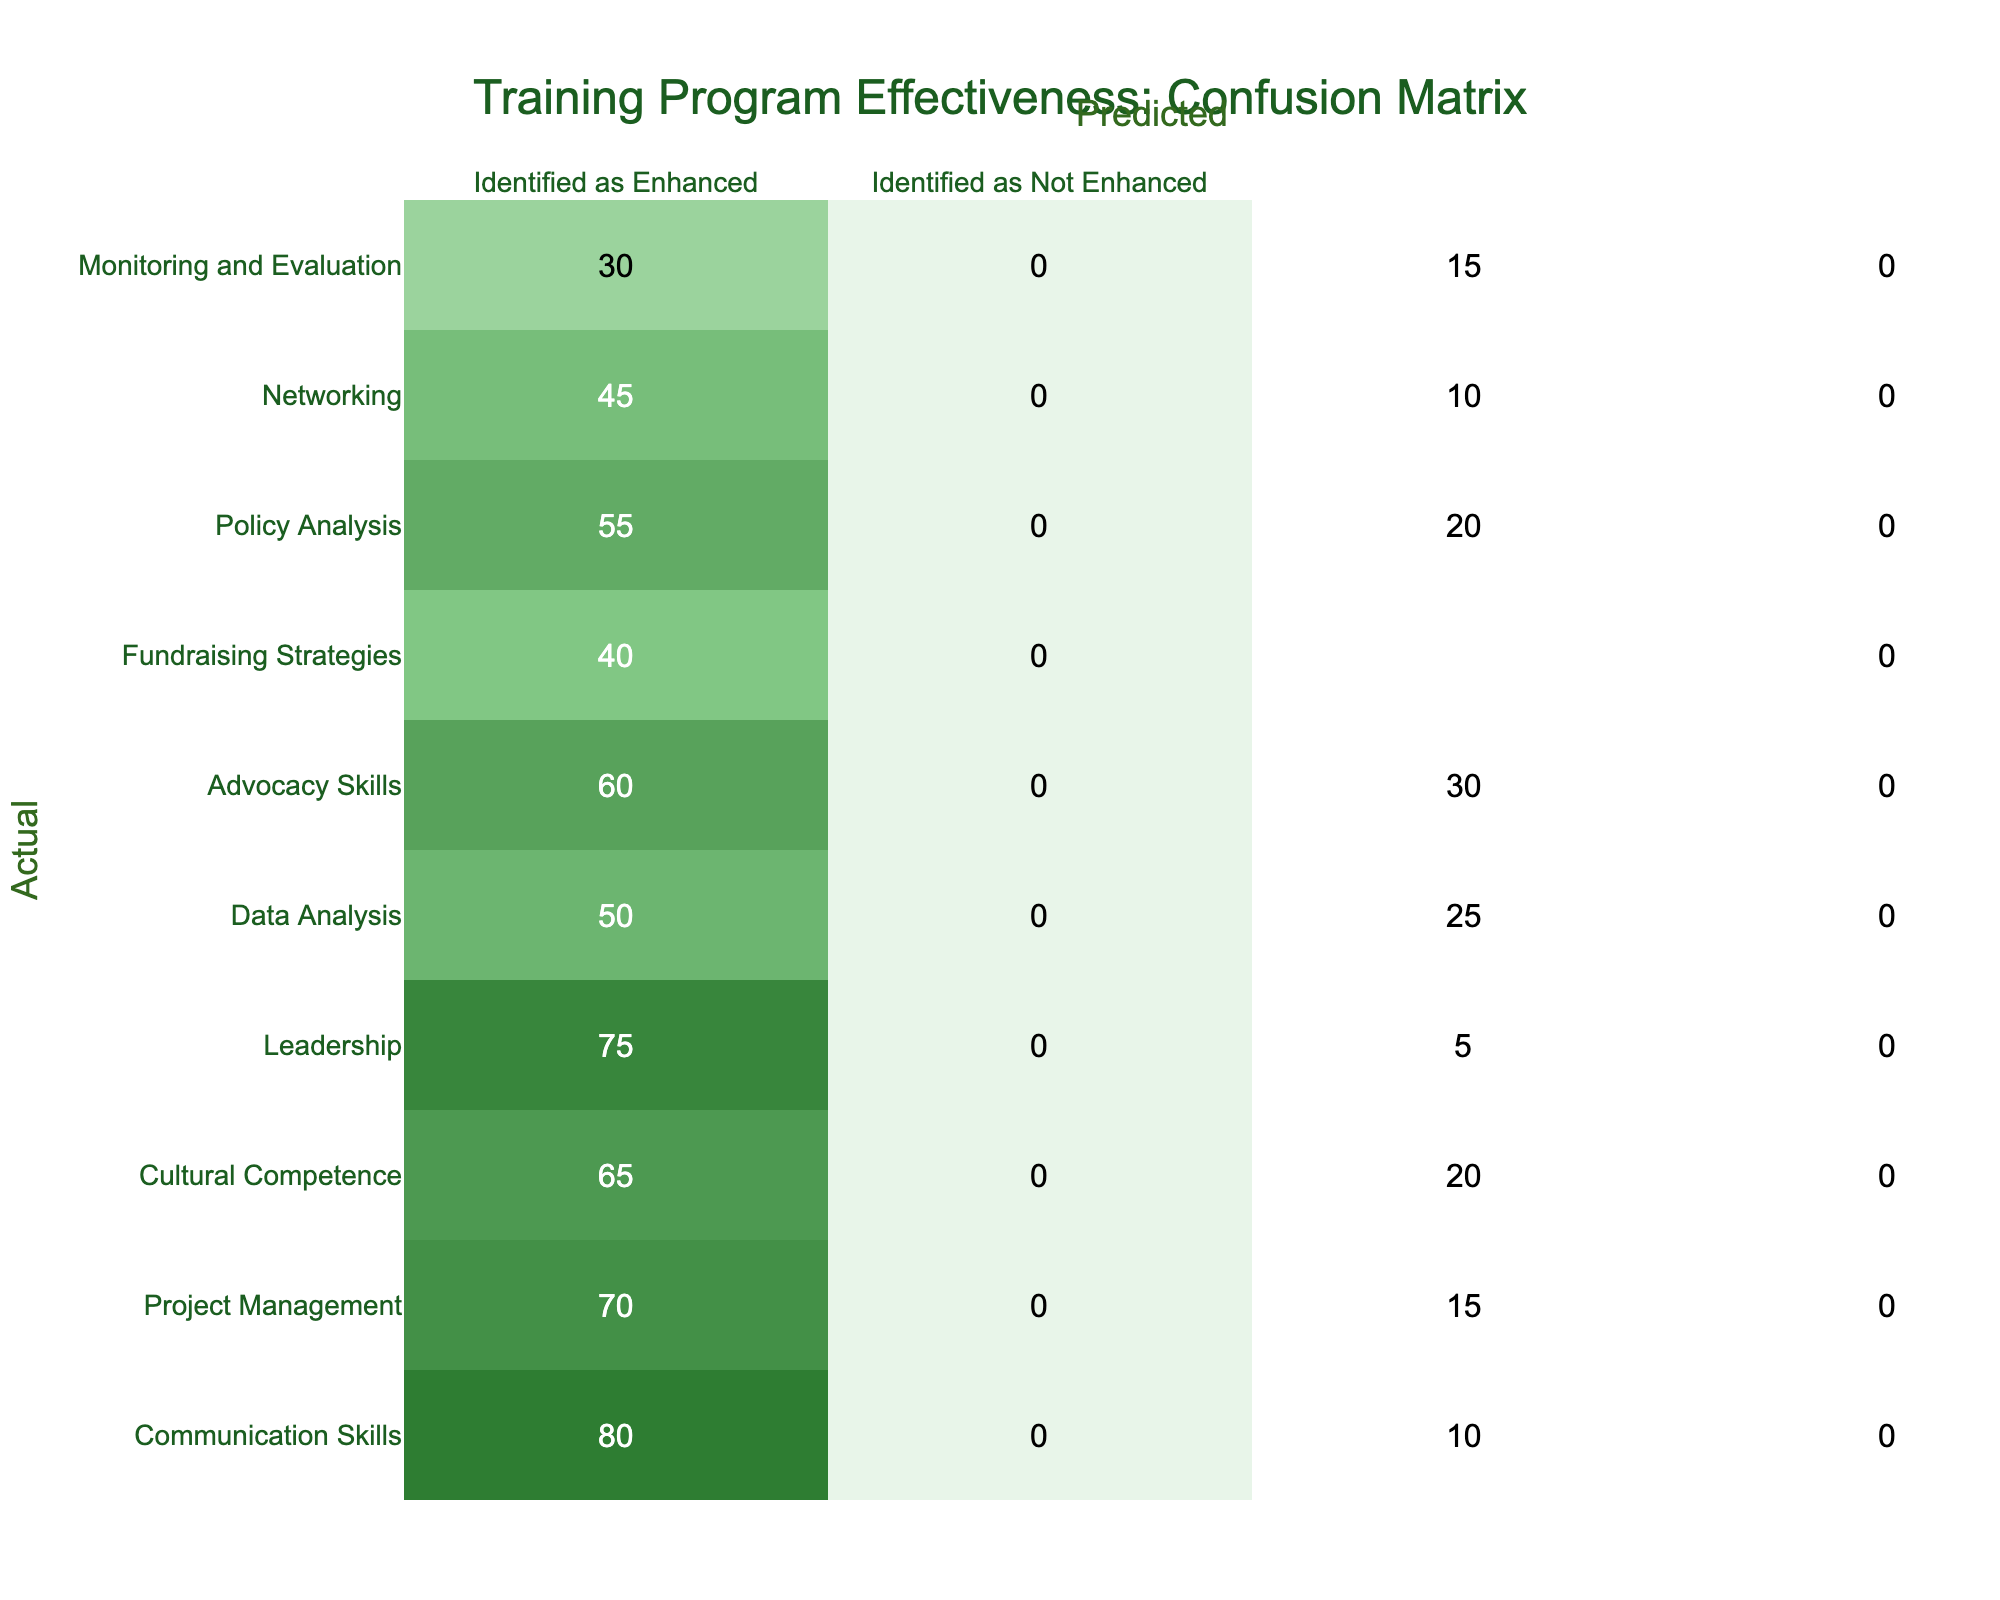What is the number of correctly identified skill enhancements for Leadership? From the table, the column for "Correctly Identified" under "Leadership" shows the value 75.
Answer: 75 What skill enhancement had the highest number of incorrectly identified skills? Looking at the "Incorrectly Identified" column, Fundraising Strategies has the highest value of 35.
Answer: 35 What is the total number of skill enhancements that were correctly identified? Adding the values from the "Correctly Identified" column: 80 + 70 + 65 + 75 + 50 + 60 + 40 + 55 + 45 + 30 = 570.
Answer: 570 Is it true that Data Analysis had more incorrectly identified enhancements than Advocacy Skills? Checking the "Incorrectly Identified" values, Data Analysis has 25 and Advocacy Skills has 30, which means Data Analysis had less. Therefore, the statement is false.
Answer: No What is the difference between the correctly identified and incorrectly identified skill enhancements for Cultural Competence? For Cultural Competence, the "Correctly Identified" value is 65 and the "Incorrectly Identified" value is 20. The difference is 65 - 20 = 45.
Answer: 45 Which skill enhancement category had the lowest total number of enhancements (correctly identified + incorrectly identified)? For Fundraising Strategies, the sum is 40 (correctly identified) + 35 (incorrectly identified) = 75; this is lower than all other categories upon checking.
Answer: Fundraising Strategies What is the average number of correctly identified skill enhancements across all categories? The total number of correctly identified skill enhancements is 570 (as calculated earlier), and there are 10 categories, so the average is 570 / 10 = 57.
Answer: 57 Is it true that there are more skills correctly identified in Communication Skills than incorrectly identified in Leadership? Communication Skills has 80 correctly identified and Leadership has 5 incorrectly identified, therefore the statement is true.
Answer: Yes Which skill category had the smallest difference between correctly identified and incorrectly identified enhancements? By calculating the differences for all categories, the smallest difference is found in Leadership, which has a difference of 70 (75 - 5).
Answer: Leadership 